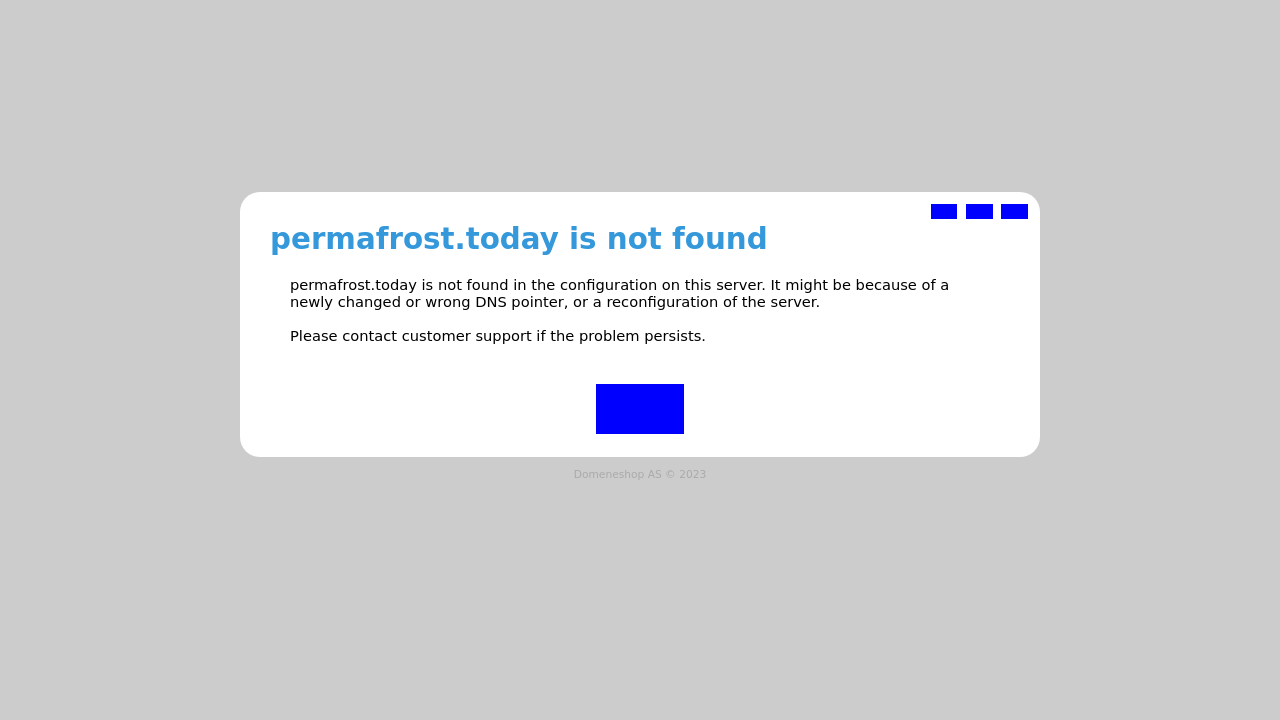What's the procedure for constructing this website from scratch with HTML? To construct a website from scratch using HTML, begin by defining the document type and setting up your HTML structure. Incorporate elements such as the header, body, and footer. For a site like 'permafrost.today', you might want to define styles in CSS for visual appeal and ensure responsiveness with meta tags. Additionally, use JavaScript for interactive elements. Finally, validate your HTML to ensure it meets web standards and test it across different browsers for compatibility. Incorporate SEO best practices to improve the site's visibility. Here is an example:
<!DOCTYPE html>
<html>
<head>
<meta charset="UTF-8">
<meta name="viewport" content="width=device-width, initial-scale=1.0">
<title>Site Title</title>
<link rel="stylesheet" type="text/css" href="style.css">
</head>
<body>
<header>
<h1>Welcome to Permafrost Today</h1>
<nav>
<ul>
<li><a href="#">Home</a></li>
<li><a href="#">About</a></li>
<li><a href="#">Services</a></li>
<li><a href="#">Contact</a></li>
</ul>
</nav>
</header>
<article>
<section>
<h2>Main Content</h2>
<p>This is the main section of the content.</p>
</section>
</article>
<footer>
<p>Copyright &copy; 2023 Permafrost Today</p>
</footer>
<script src="script.js"></script>
</body>
</html> 